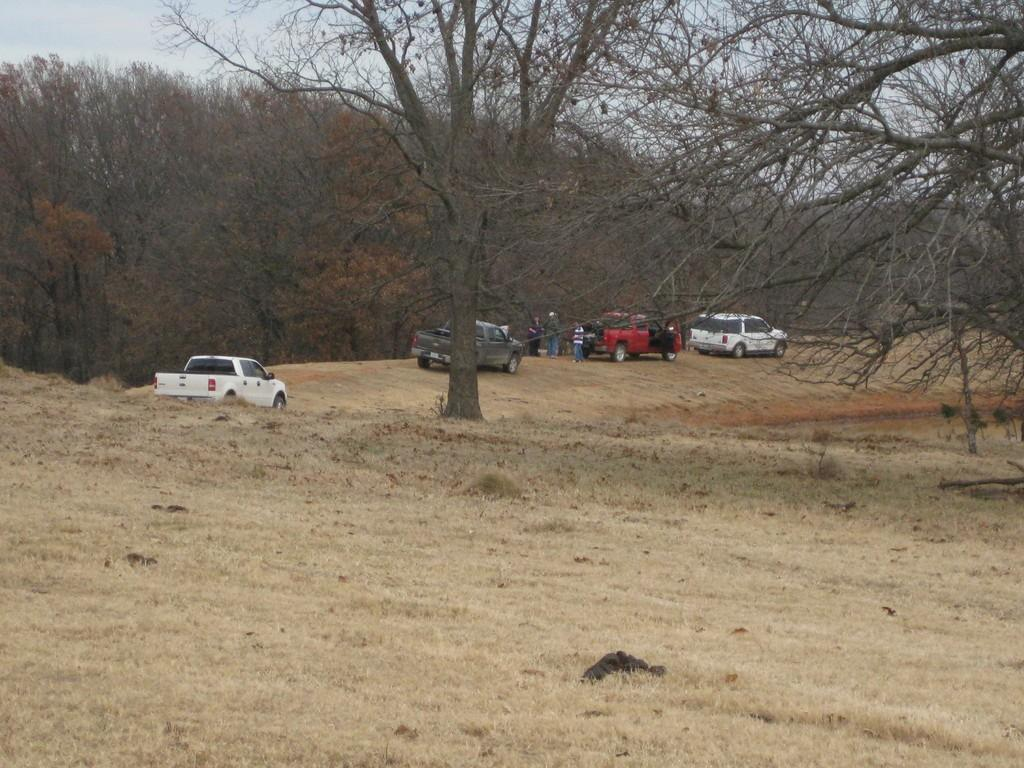Who or what can be seen in the image? There are people in the image. What else is present in the image besides people? There are trees and vehicles on the ground in the image. What can be seen in the background of the image? The sky is visible in the background of the image. What type of jelly is being served at the holiday event in the image? There is no holiday event or jelly present in the image. 